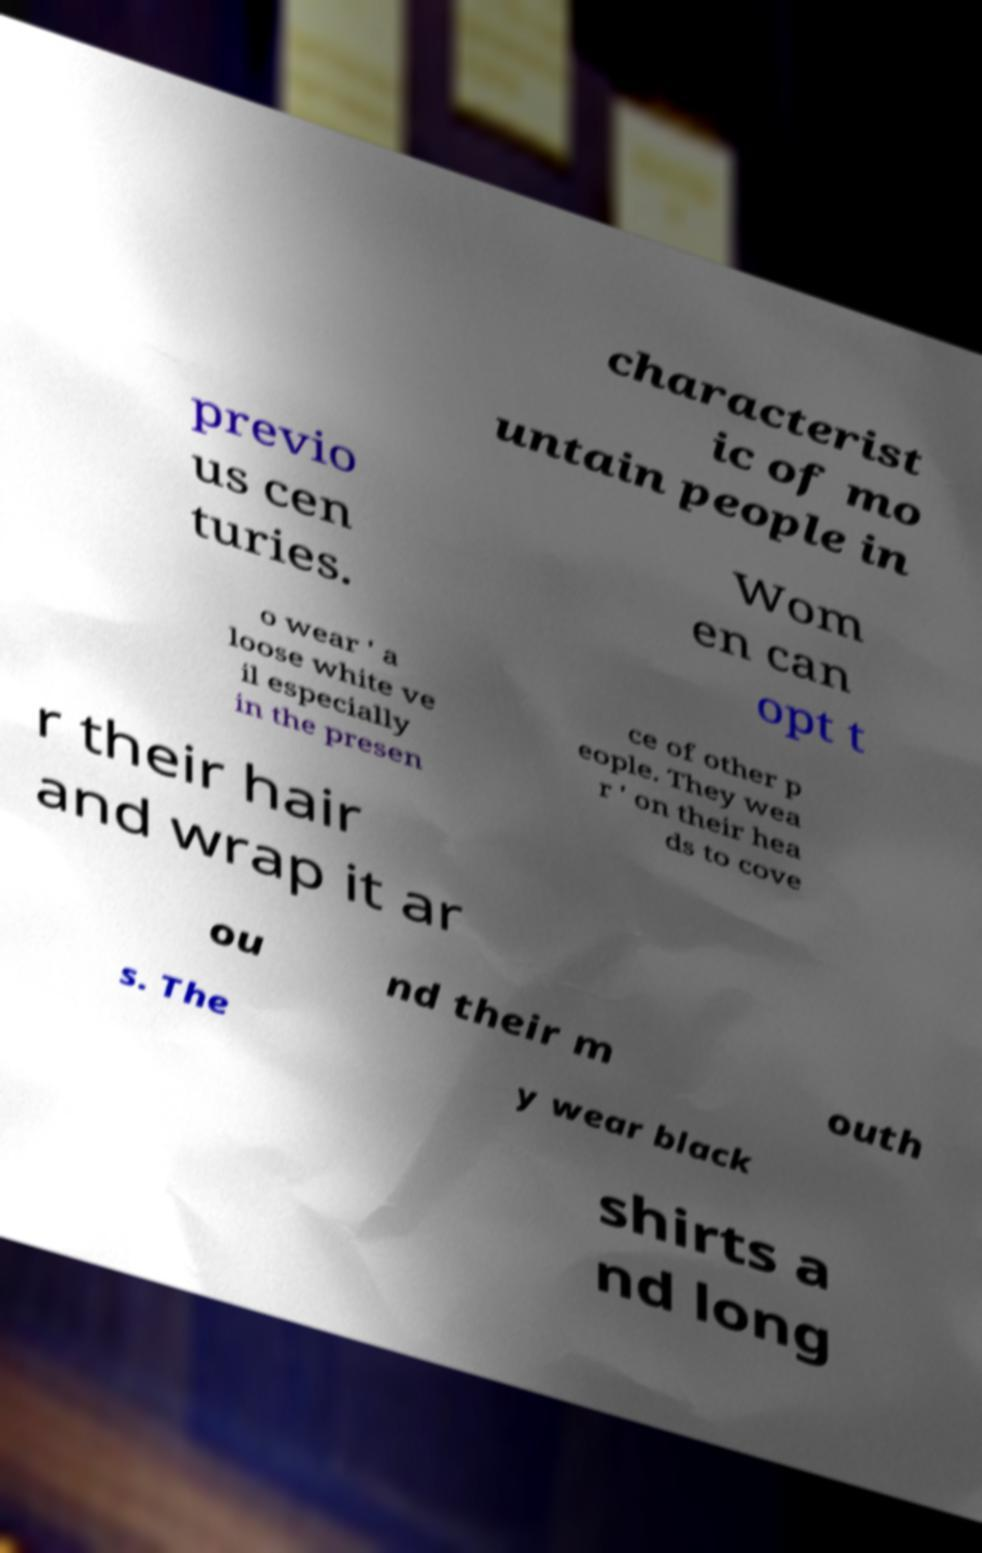Please read and relay the text visible in this image. What does it say? characterist ic of mo untain people in previo us cen turies. Wom en can opt t o wear ' a loose white ve il especially in the presen ce of other p eople. They wea r ' on their hea ds to cove r their hair and wrap it ar ou nd their m outh s. The y wear black shirts a nd long 